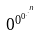<formula> <loc_0><loc_0><loc_500><loc_500>0 ^ { 0 ^ { 0 ^ { . ^ { . ^ { n } } } } }</formula> 